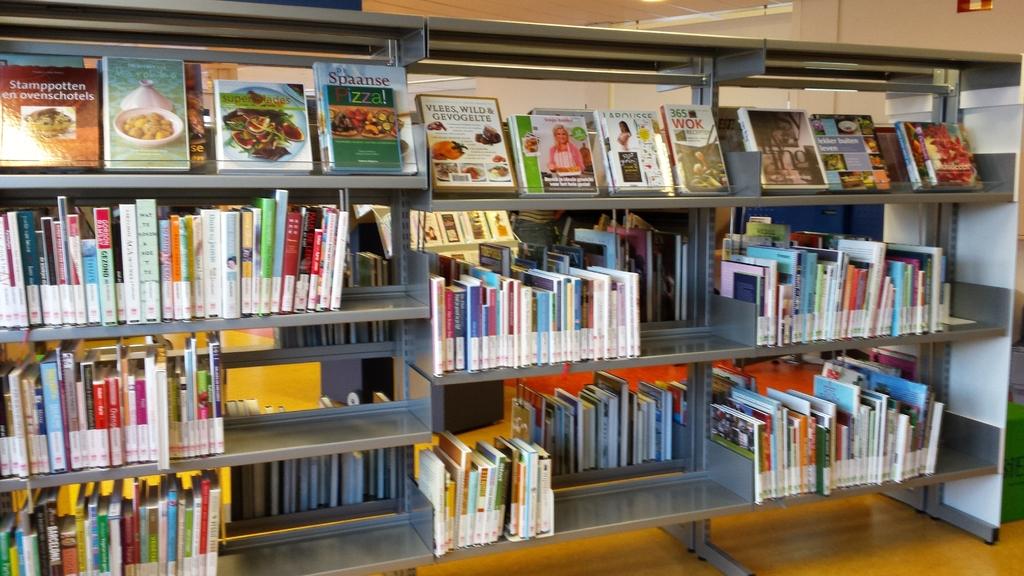The fourth book from the right on this shelf, what words is printed under the number 365?
Keep it short and to the point. Wok. What is the title of the book on the upper left?
Give a very brief answer. Stamppotten en ovenschotels. 